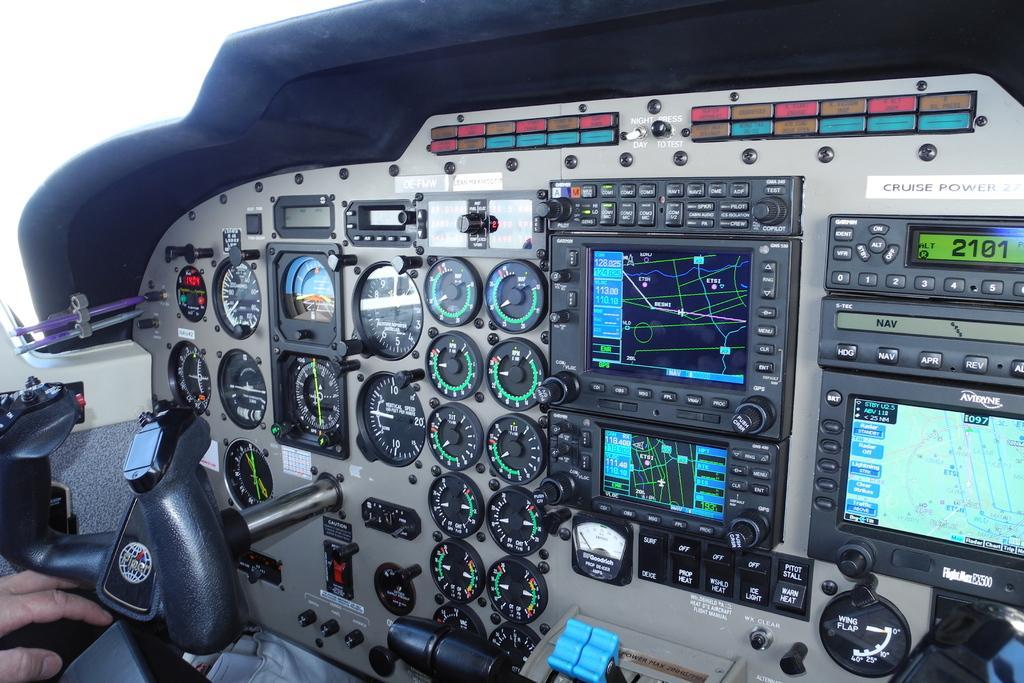Please provide a concise description of this image. In this picture we can observe piper Seneca cockpit of an aircraft. We can observe some meters and three screens in this picture. On the left side we can observe a human hand. There is a blue color lever in this picture. 